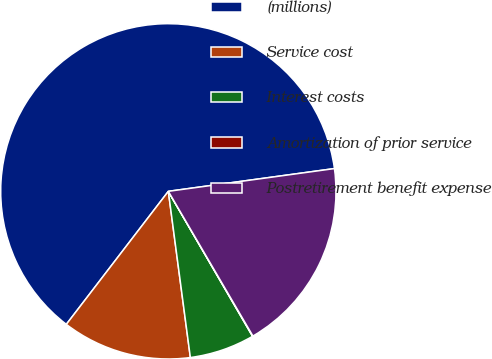Convert chart. <chart><loc_0><loc_0><loc_500><loc_500><pie_chart><fcel>(millions)<fcel>Service cost<fcel>Interest costs<fcel>Amortization of prior service<fcel>Postretirement benefit expense<nl><fcel>62.42%<fcel>12.51%<fcel>6.28%<fcel>0.04%<fcel>18.75%<nl></chart> 